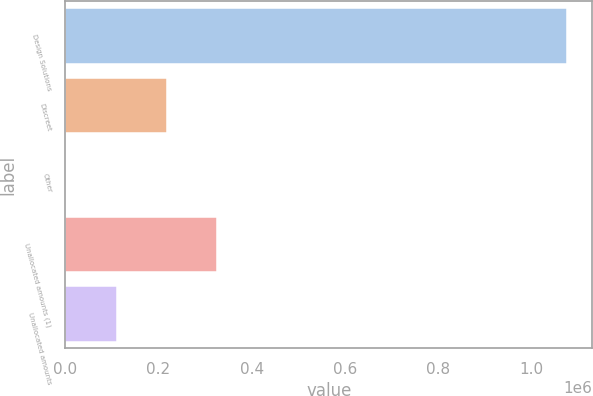Convert chart to OTSL. <chart><loc_0><loc_0><loc_500><loc_500><bar_chart><fcel>Design Solutions<fcel>Discreet<fcel>Other<fcel>Unallocated amounts (1)<fcel>Unallocated amounts<nl><fcel>1.07726e+06<fcel>217410<fcel>2447<fcel>324892<fcel>109929<nl></chart> 